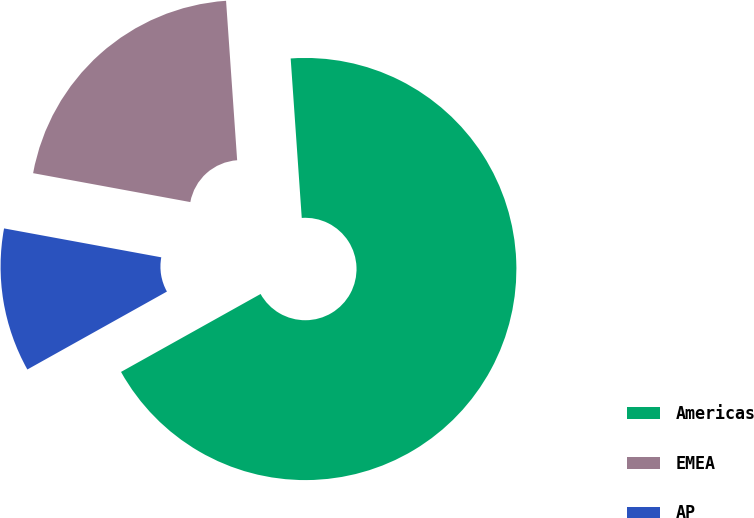Convert chart. <chart><loc_0><loc_0><loc_500><loc_500><pie_chart><fcel>Americas<fcel>EMEA<fcel>AP<nl><fcel>68.0%<fcel>21.0%<fcel>11.0%<nl></chart> 